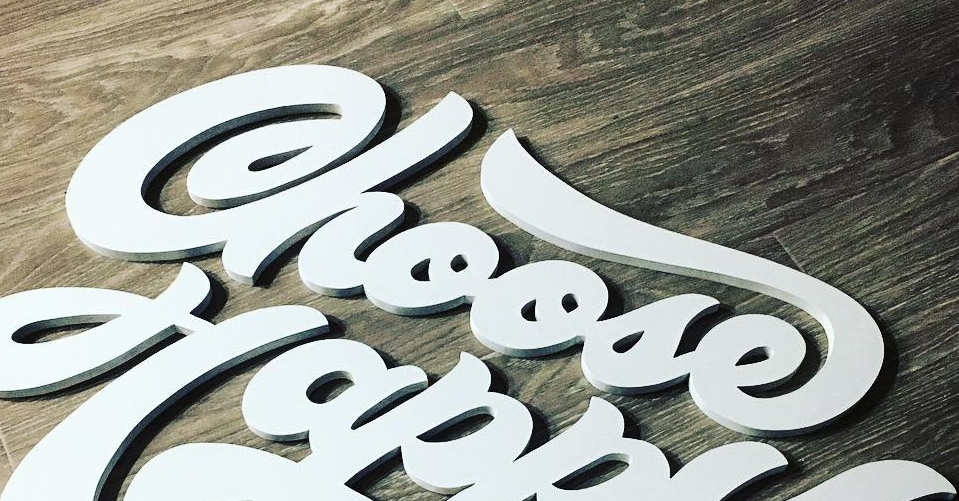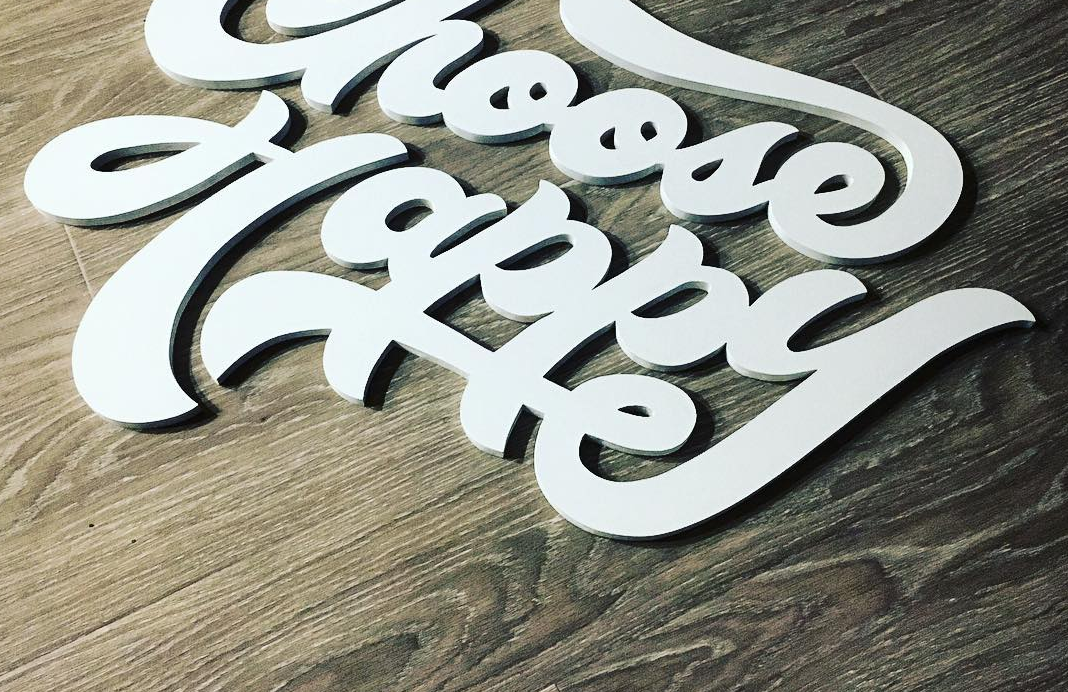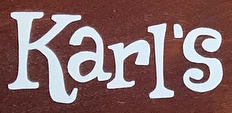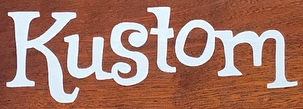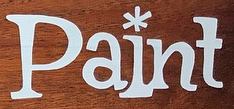Transcribe the words shown in these images in order, separated by a semicolon. Choose; Happy; Karl's; Kustom; Paint 